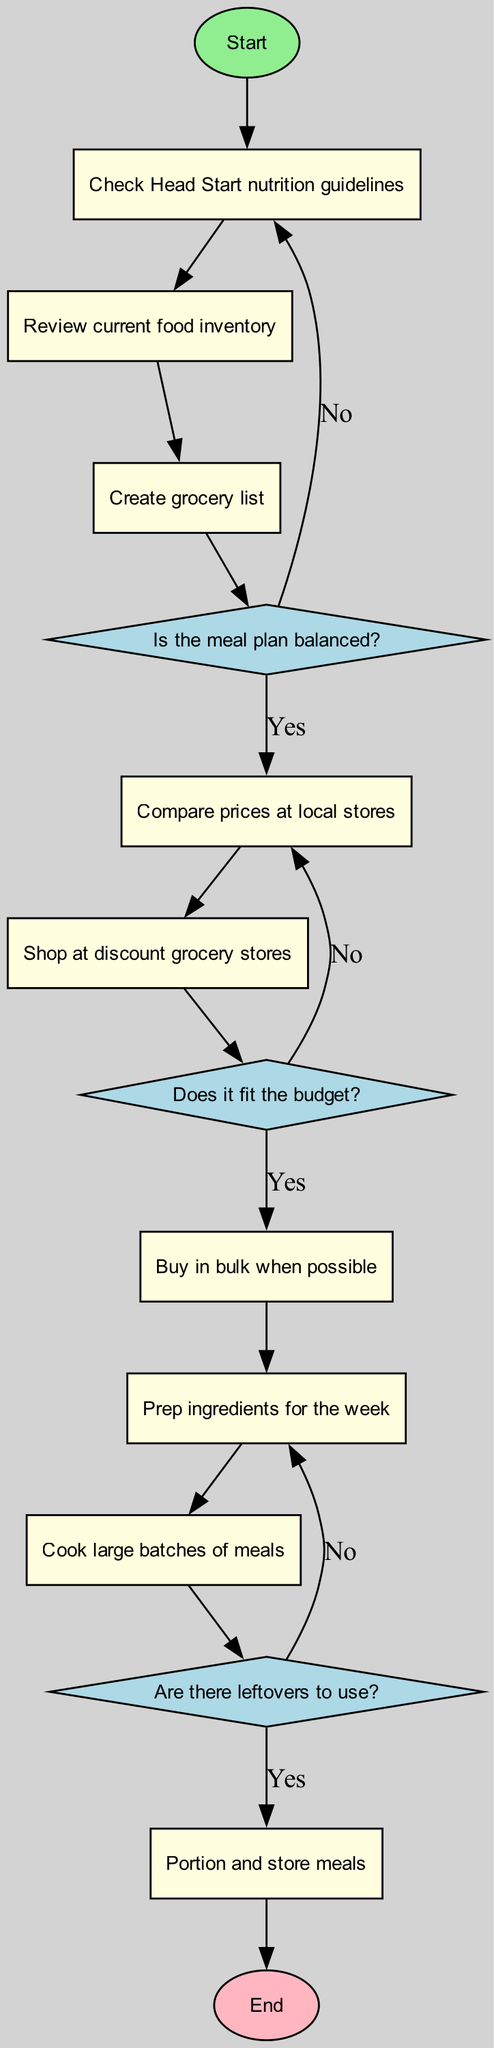What is the first activity in the diagram? The first activity directly follows the start node in the diagram, which is "Check Head Start nutrition guidelines."
Answer: Check Head Start nutrition guidelines What is the last activity before finalizing the meal plan? The last activity before the end node is "Portion and store meals." This can be determined by following the flow from the last activity through to the end node.
Answer: Portion and store meals How many decisions are in the diagram? There are three decision nodes in the diagram, identified as those marked in diamond shapes.
Answer: 3 What happens if the meal plan is not balanced? If the meal plan is not balanced, the path returns to "Create grocery list," following the decision node related to balanced meal plans.
Answer: Create grocery list Which activity follows comparing prices at local stores? After "Compare prices at local stores," the next activity is "Shop at discount grocery stores," shown by the directed edge connecting those two nodes.
Answer: Shop at discount grocery stores Is there a decision regarding using leftovers? Yes, there is a decision node that addresses leftovers, specifically "Are there leftovers to use?" This is clearly indicated in the flow of the diagram leading to post-cooking activities.
Answer: Yes What is the activity directly after cooking large batches of meals? The activity directly following "Cook large batches of meals" is "Portion and store meals," as indicated by the connecting edge.
Answer: Portion and store meals What activity does the decision about fitting the budget lead to if the answer is "No"? If the budget decision is answered with "No," the flow directs back to "Compare prices at local stores," according to the diagram's decision structure.
Answer: Compare prices at local stores 